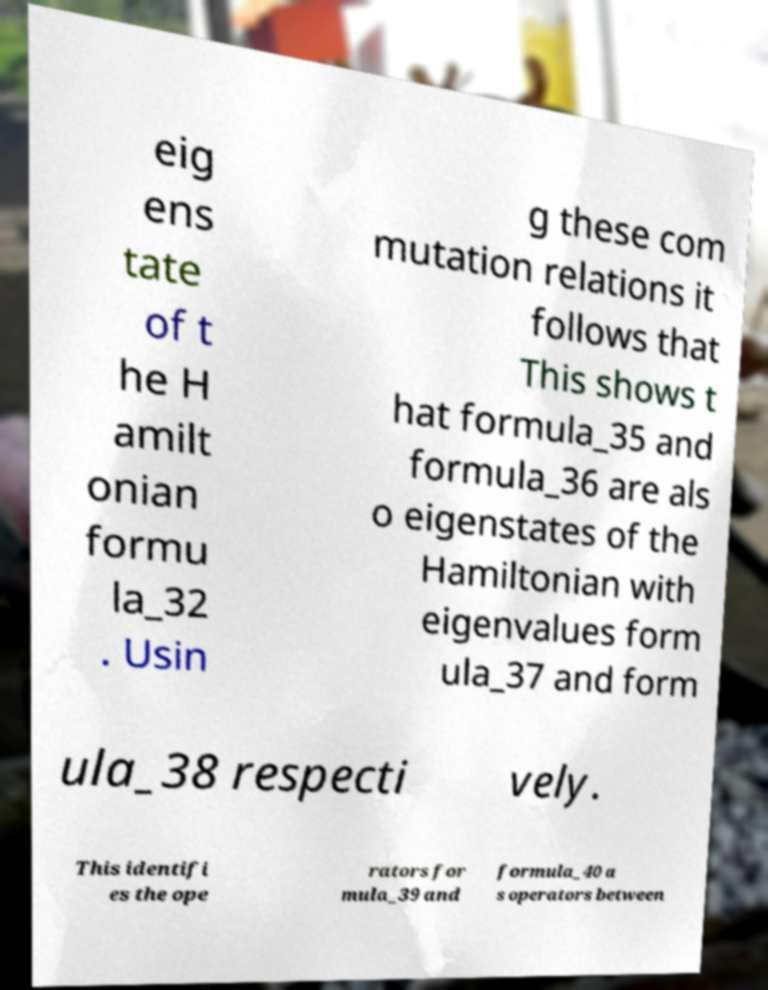Could you extract and type out the text from this image? eig ens tate of t he H amilt onian formu la_32 . Usin g these com mutation relations it follows that This shows t hat formula_35 and formula_36 are als o eigenstates of the Hamiltonian with eigenvalues form ula_37 and form ula_38 respecti vely. This identifi es the ope rators for mula_39 and formula_40 a s operators between 